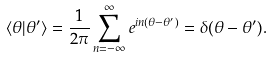<formula> <loc_0><loc_0><loc_500><loc_500>\langle \theta | \theta ^ { \prime } \rangle = \frac { 1 } { 2 \pi } \sum ^ { \infty } _ { n = - \infty } e ^ { i n ( \theta - \theta ^ { \prime } ) } = \delta ( \theta - \theta ^ { \prime } ) .</formula> 